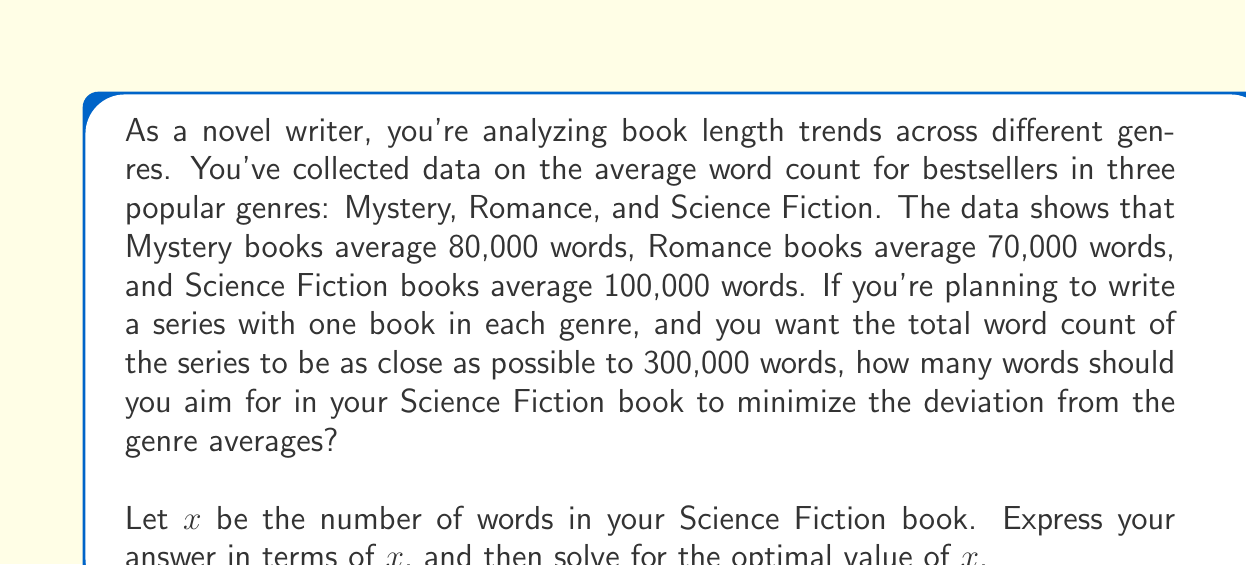Provide a solution to this math problem. To solve this problem, we need to minimize the total deviation from the genre averages while maintaining a total word count close to 300,000. Let's approach this step-by-step:

1) First, let's define our variables:
   - Mystery book: 80,000 words (fixed)
   - Romance book: 70,000 words (fixed)
   - Science Fiction book: $x$ words (variable)

2) The total word count of the series should be 300,000 words:

   $80,000 + 70,000 + x = 300,000$

3) We want to minimize the deviation from genre averages. We can express this as the sum of squared differences:

   $(80,000 - 80,000)^2 + (70,000 - 70,000)^2 + (x - 100,000)^2$

4) The first two terms are zero, so we're left with:

   $(x - 100,000)^2$

5) We want to minimize this expression while satisfying the constraint from step 2. We can solve for $x$ using the constraint:

   $x = 300,000 - 80,000 - 70,000 = 150,000$

6) Therefore, the optimal value for $x$ is 150,000 words.

7) To verify this is a minimum, we can check the second derivative of our objective function:

   $\frac{d^2}{dx^2}(x - 100,000)^2 = 2 > 0$

   This confirms that our solution is indeed a minimum.
Answer: The optimal word count for the Science Fiction book is 150,000 words. This solution minimizes the deviation from genre averages while meeting the total word count constraint of 300,000 words for the series. 